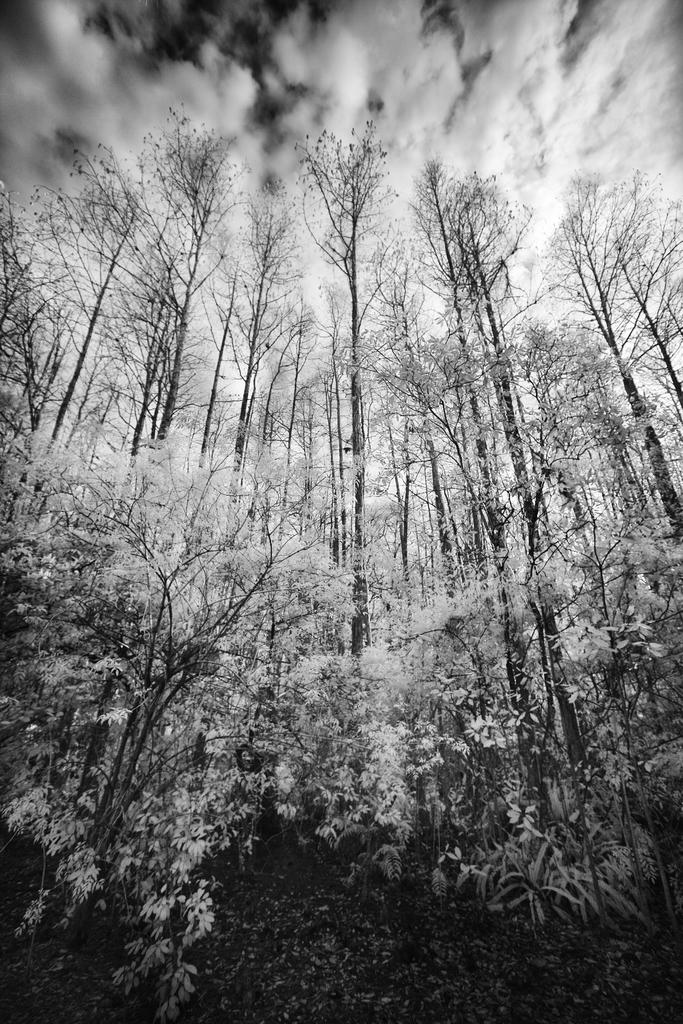What type of environment might the image be taken in? The image might be taken in a forest, given the presence of trees. What can be seen in the foreground of the image? There are trees in the foreground of the image. What is visible at the top of the image? The sky is visible at the top of the image. Can you see the daughter holding a balloon in the image? There is no daughter or balloon present in the image. Is there a skate visible on the ground in the image? There is no skate visible on the ground in the image. 